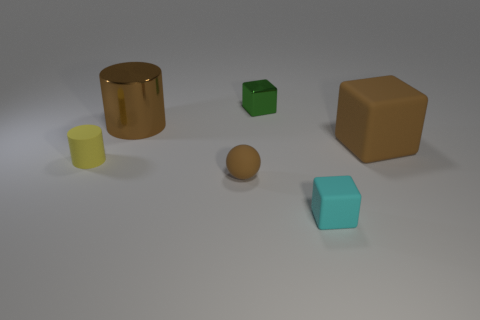Subtract all tiny cyan matte blocks. How many blocks are left? 2 Subtract all green cubes. How many cubes are left? 2 Add 3 rubber cylinders. How many objects exist? 9 Subtract 1 balls. How many balls are left? 0 Subtract all spheres. How many objects are left? 5 Add 3 yellow rubber objects. How many yellow rubber objects are left? 4 Add 1 rubber things. How many rubber things exist? 5 Subtract 0 purple spheres. How many objects are left? 6 Subtract all gray balls. Subtract all cyan cubes. How many balls are left? 1 Subtract all gray cylinders. How many yellow spheres are left? 0 